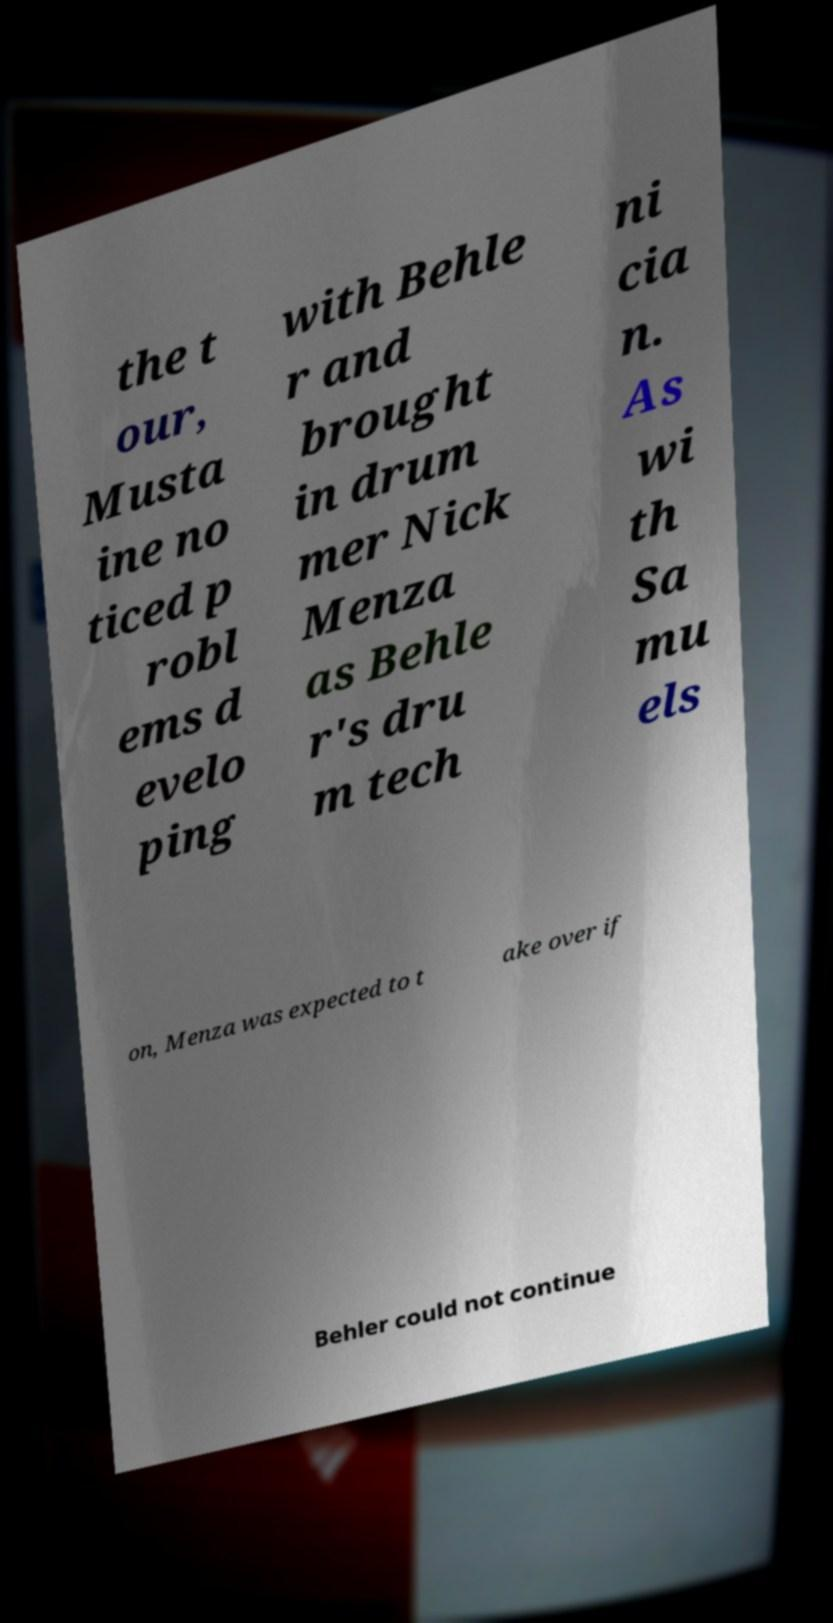What messages or text are displayed in this image? I need them in a readable, typed format. the t our, Musta ine no ticed p robl ems d evelo ping with Behle r and brought in drum mer Nick Menza as Behle r's dru m tech ni cia n. As wi th Sa mu els on, Menza was expected to t ake over if Behler could not continue 